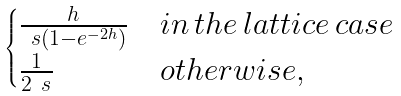Convert formula to latex. <formula><loc_0><loc_0><loc_500><loc_500>\begin{cases} \frac { h } { \ s ( 1 - e ^ { - 2 h } ) } & i n \, t h e \, l a t t i c e \, c a s e \\ \frac { 1 } { 2 \ s } & o t h e r w i s e , \end{cases}</formula> 